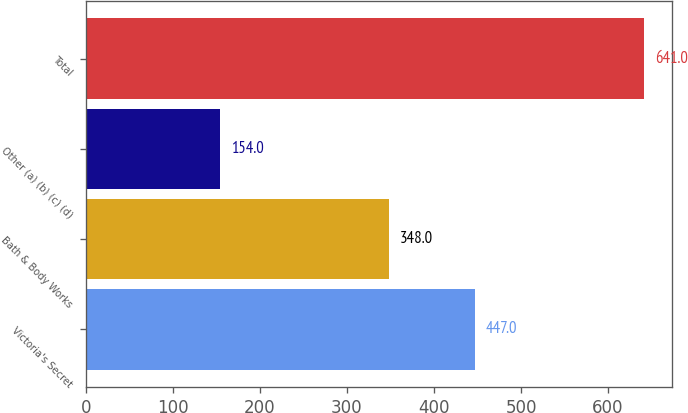Convert chart to OTSL. <chart><loc_0><loc_0><loc_500><loc_500><bar_chart><fcel>Victoria's Secret<fcel>Bath & Body Works<fcel>Other (a) (b) (c) (d)<fcel>Total<nl><fcel>447<fcel>348<fcel>154<fcel>641<nl></chart> 